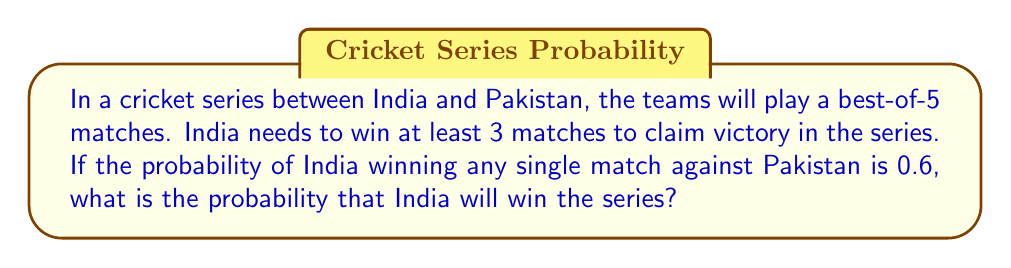Could you help me with this problem? Let's approach this step-by-step using combinatorics and probability theory:

1) India can win the series in three ways:
   - Winning 3 matches out of 5
   - Winning 4 matches out of 5
   - Winning all 5 matches

2) Let's calculate the probability of each scenario:

   a) Probability of winning exactly 3 matches:
      $P(3 \text{ wins}) = \binom{5}{3} \cdot (0.6)^3 \cdot (0.4)^2$
      $= 10 \cdot 0.216 \cdot 0.16 = 0.3456$

   b) Probability of winning exactly 4 matches:
      $P(4 \text{ wins}) = \binom{5}{4} \cdot (0.6)^4 \cdot (0.4)^1$
      $= 5 \cdot 0.1296 \cdot 0.4 = 0.2592$

   c) Probability of winning all 5 matches:
      $P(5 \text{ wins}) = \binom{5}{5} \cdot (0.6)^5$
      $= 1 \cdot 0.07776 = 0.07776$

3) The total probability of winning the series is the sum of these probabilities:

   $P(\text{winning series}) = P(3 \text{ wins}) + P(4 \text{ wins}) + P(5 \text{ wins})$
   $= 0.3456 + 0.2592 + 0.07776$
   $= 0.68256$

4) Therefore, the probability that India will win the series is approximately 0.6826 or 68.26%.
Answer: $0.68256$ or $68.26\%$ 